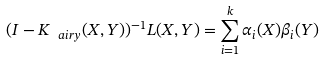<formula> <loc_0><loc_0><loc_500><loc_500>( I - K _ { \ a i r y } ( X , Y ) ) ^ { - 1 } L ( X , Y ) = \sum _ { i = 1 } ^ { k } \alpha _ { i } ( X ) \beta _ { i } ( Y )</formula> 